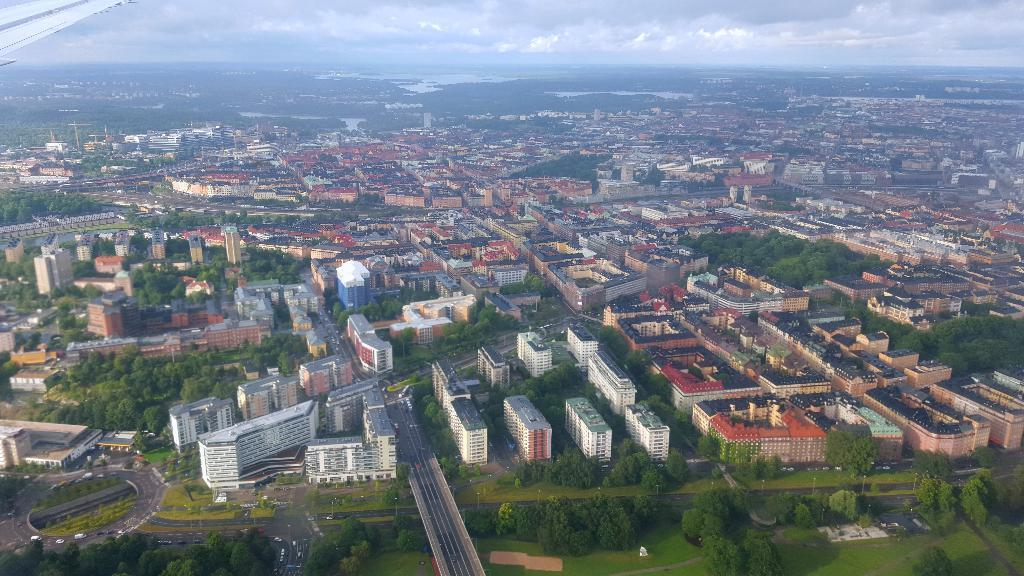What is the perspective of the image? The image is captured from a plane. What can be seen in the image from this perspective? There is a big city in the image. How many buildings are visible in the city? The city has many buildings. What type of natural environment is present in the city? There is greenery in the city. What type of chess pieces can be seen on the rooftops of the buildings in the image? There are no chess pieces visible on the rooftops of the buildings in the image. Can you tell me how many teeth are visible on the dinosaurs in the image? There are no dinosaurs present in the image, so no teeth can be observed. 